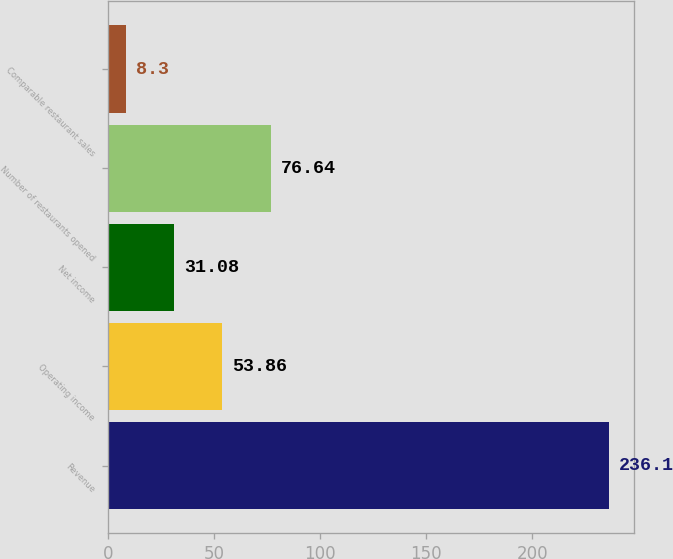Convert chart to OTSL. <chart><loc_0><loc_0><loc_500><loc_500><bar_chart><fcel>Revenue<fcel>Operating income<fcel>Net income<fcel>Number of restaurants opened<fcel>Comparable restaurant sales<nl><fcel>236.1<fcel>53.86<fcel>31.08<fcel>76.64<fcel>8.3<nl></chart> 